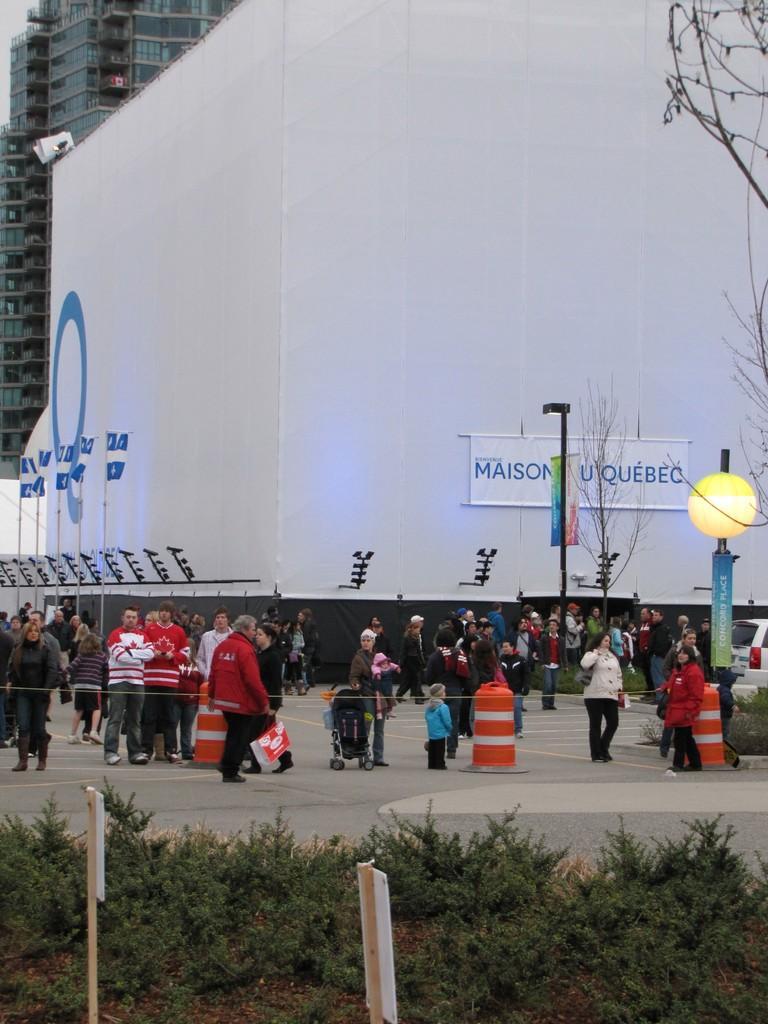Could you give a brief overview of what you see in this image? In the image there are many people standing and walking on the road, behind them there is a building with flags in front of it along with trees and poles and over the back of it there is another building, in the front of the image there are plants. 